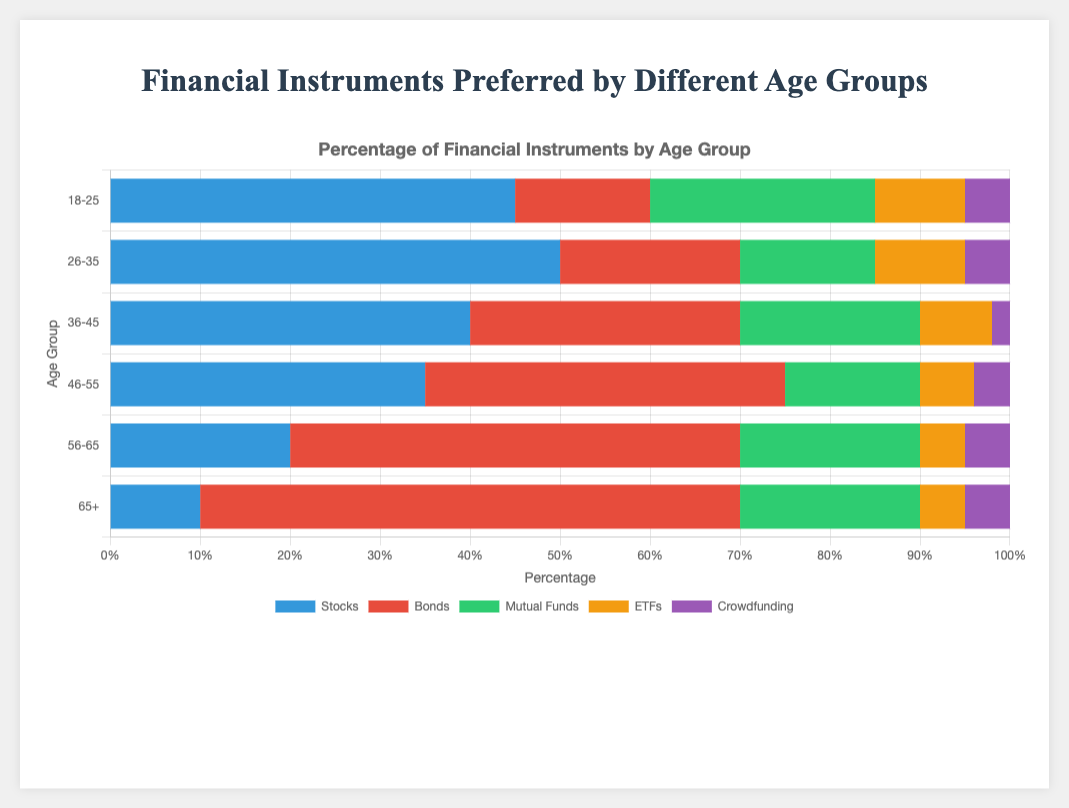which age group has the highest preference for bonds? The '65+' age group has the highest percentage for bonds, which is evident from the longest red bar in the Bonds category.
Answer: 65+ what's the total percentage of traditional instruments (stocks, bonds, mutual funds) preferred by the 18-25 age group? Add the percentages of stocks (45), bonds (15), and mutual funds (25) for the 18-25 age group: 45 + 15 + 25 = 85%.
Answer: 85% how does the preference for stocks in the 26-35 age group compare to that in the 65+ age group? The percentage for stocks in the 26-35 age group is 50%, while in the 65+ age group is 10%. Therefore, the 26-35 age group prefers stocks significantly more than the 65+ age group by a difference of 40%.
Answer: 26-35 prefers more which has a greater percentage in the 46-55 age group, ETFs or Crowdfunding? The chart shows that the 46-55 age group has 6% for ETFs and 4% for Crowdfunding. Thus, ETFs are preferred more.
Answer: ETFs what is the average percentage of mutual funds across all age groups? Total percentages of mutual funds across all age groups are: 25 + 15 + 20 + 15 + 20 + 20 = 115%. There are 6 age groups, so the average is 115 / 6 ≈ 19.17%.
Answer: 19.17% which age group has the lowest preference for mutual funds? According to the chart, the 26-35 and 46-55 age groups both prefer mutual funds at 15%, which is the lowest among the age groups.
Answer: 26-35 and 46-55 compare the visual lengths of the bars for stocks in the 18-25 and 36-45 age groups. The visual length for stocks in the 18-25 age group is longer than that in the 36-45 age group. Specifically, the 18-25 age group has 45%, while the 36-45 age group has 40%.
Answer: 18-25 is longer what's the combined percentage for less traditional investments (ETFs and Crowdfunding) in the 56-65 age group? Add the percentages for ETFs (5) and Crowdfunding (5) in the 56-65 age group: 5 + 5 = 10%.
Answer: 10% what is the change in preference for bonds from the 18-25 age group to the 65+ age group? Subtract the percentage of bonds in the 18-25 age group (15%) from the 65+ age group (60%): 60 - 15 = 45% increase.
Answer: 45% which age group shows the highest diversity in financial instrument preference based on the percentage distribution? The 18-25 age group shows the highest diversity as the percentages are more evenly distributed across categories compared to other age groups.
Answer: 18-25 